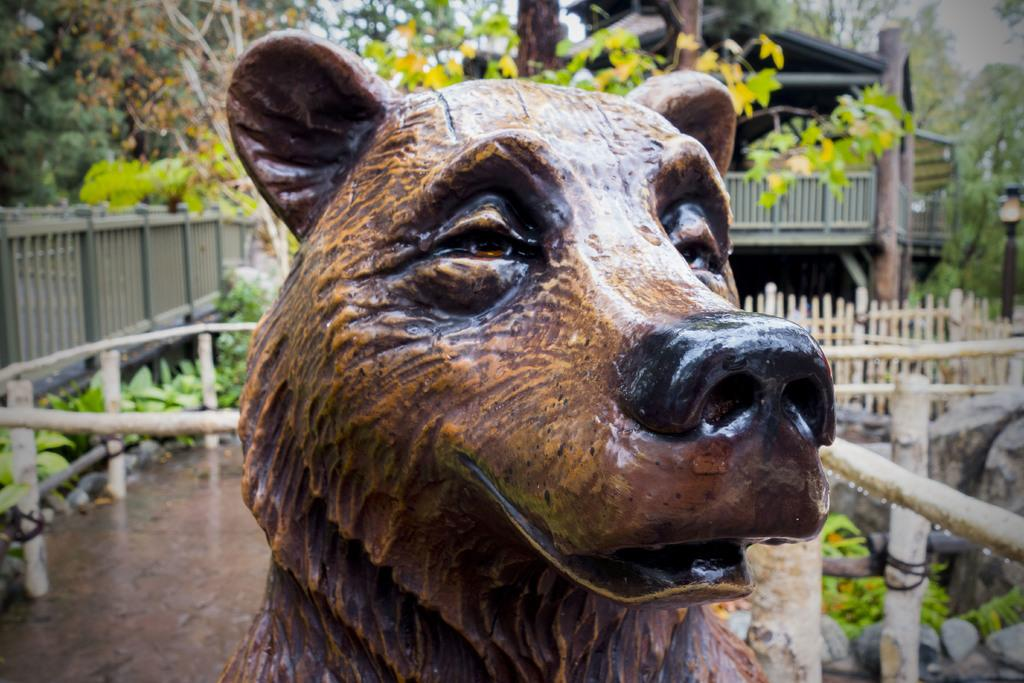What type of object is the main subject in the image? There is an animal statue in the image. What can be seen in the background of the image? There are light poles and wooden fencing in the background of the image. What type of vegetation is present in the image? There are trees with green color in the image. What is the color of the sky in the image? The sky appears to be white in color. Where is the goat sitting on the sofa in the image? There is no goat or sofa present in the image. 